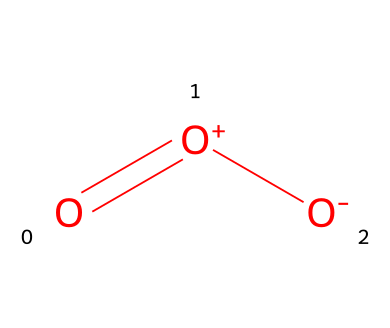What is the name of this chemical? The SMILES representation O=[O+][O-] represents ozone, which is a triatomic molecule consisting of three oxygen atoms.
Answer: ozone How many bonds are present in this structure? The structure indicates there are two bonds: one between the first oxygen and the second oxygen (double bond), and another single bond between the second and third oxygen.
Answer: 2 How many oxygen atoms are in ozone? Analyzing the SMILES representation shows three oxygen atoms involved, as noted by the presence of three "O" in the formula.
Answer: 3 What type of molecule is ozone classified as? Ozone is a molecular gas at room temperature and pressure, due to its properties and gaseous state.
Answer: gas What charge is indicated on the first and second oxygen atoms? The first oxygen atom denoted as [O+] indicates a positive charge, and the second oxygen atom denoted as [O-] signifies a negative charge.
Answer: + and - Why is ozone considered a pollutant at outdoor racing events? Ozone is a pollutant because it can cause respiratory problems and other health issues, particularly in areas with high emissions from vehicles and racing activities, leading to increased ozone formation.
Answer: health issues 